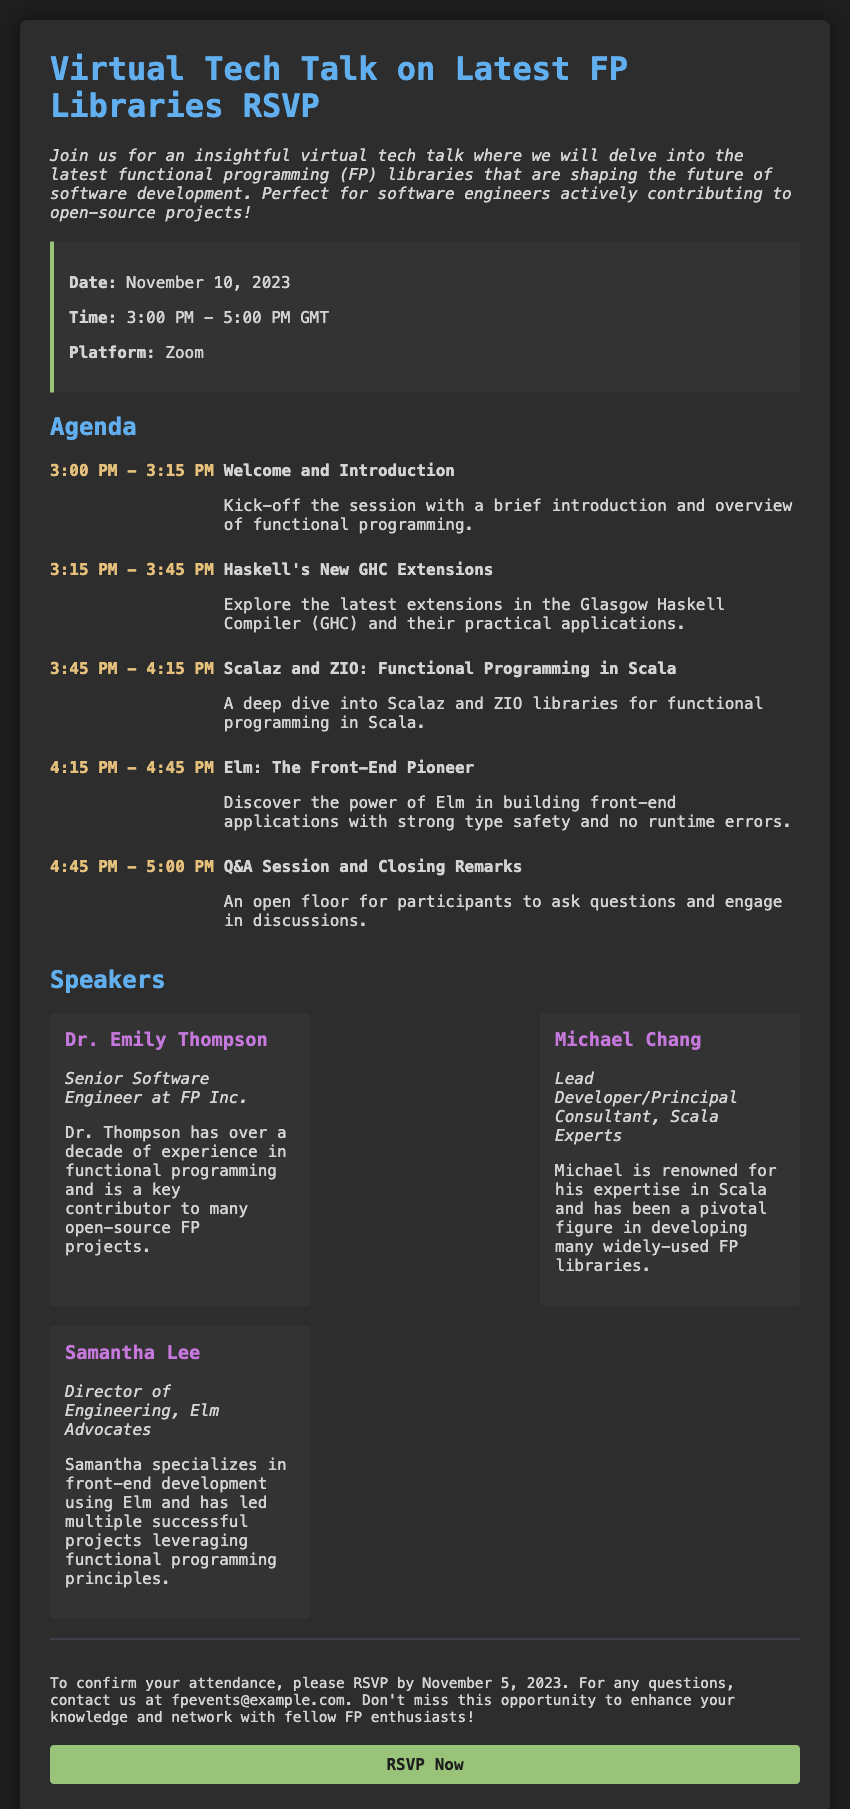What is the date of the event? The date of the event is mentioned in the event details section of the document.
Answer: November 10, 2023 What time does the event start? The start time of the event is provided alongside the date in the event details section.
Answer: 3:00 PM What platform will the event be held on? The platform for the event is specified in the event details section.
Answer: Zoom Who is the speaker for Haskell's New GHC Extensions? The agenda lists the talk on Haskell and the speaker associated with it.
Answer: Michael Chang What is the main focus of Elm presentation? The description of the Elm talk in the agenda provides insight into its focus.
Answer: Front-end applications How long is the Q&A Session scheduled for? The time allocated for the Q&A session is detailed in the agenda section.
Answer: 15 minutes What is the RSVP deadline? The RSVP deadline is specified in the additional info section of the document.
Answer: November 5, 2023 What is the profession of Dr. Emily Thompson? The speaker's information section reveals the profession of Dr. Emily Thompson.
Answer: Senior Software Engineer What is the purpose of the event? The introduction paragraph explains the overall purpose of the event.
Answer: Enhance knowledge and network 